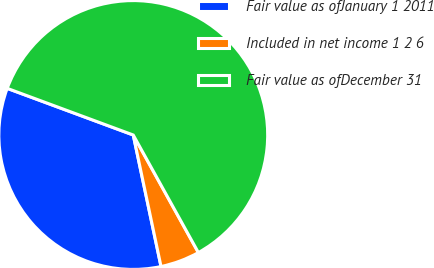Convert chart. <chart><loc_0><loc_0><loc_500><loc_500><pie_chart><fcel>Fair value as ofJanuary 1 2011<fcel>Included in net income 1 2 6<fcel>Fair value as ofDecember 31<nl><fcel>33.95%<fcel>4.74%<fcel>61.3%<nl></chart> 